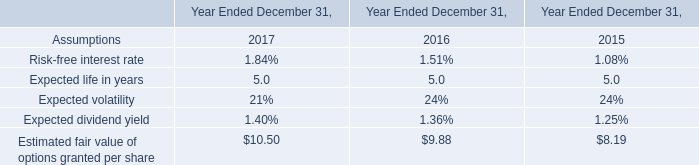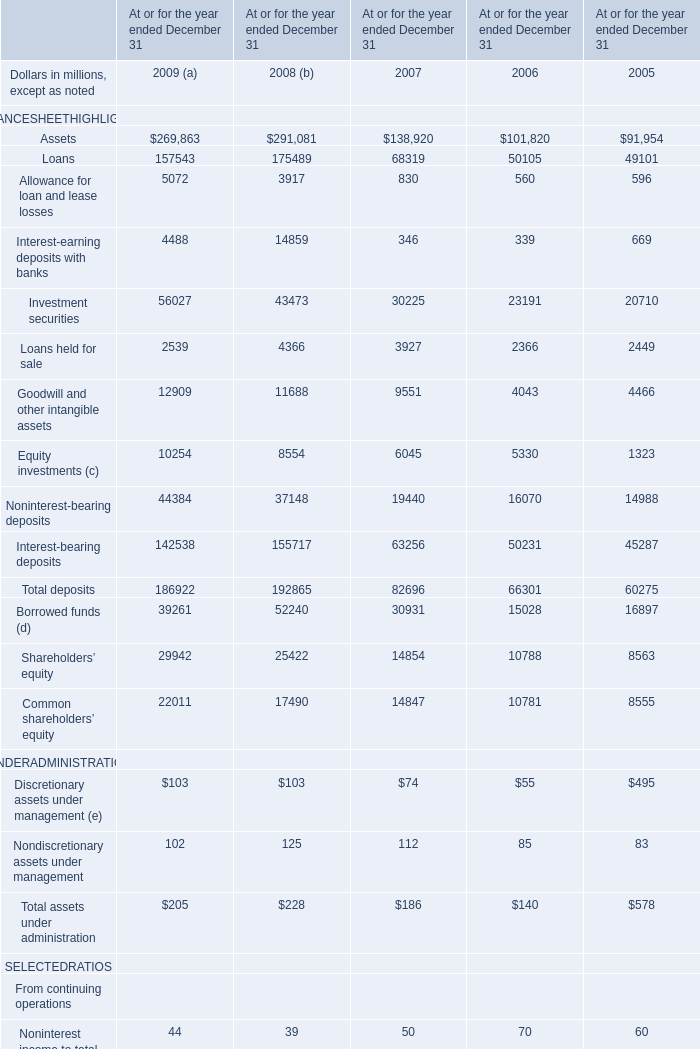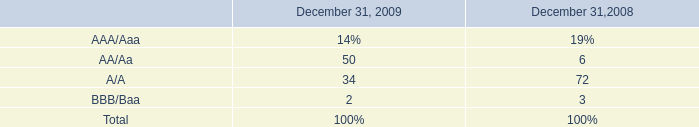What will Assets reach in 2010 if it continues to grow at its current rate? (in million) 
Computations: (269863 * (1 + ((269863 - 291081) / 291081)))
Answer: 250191.66063. 